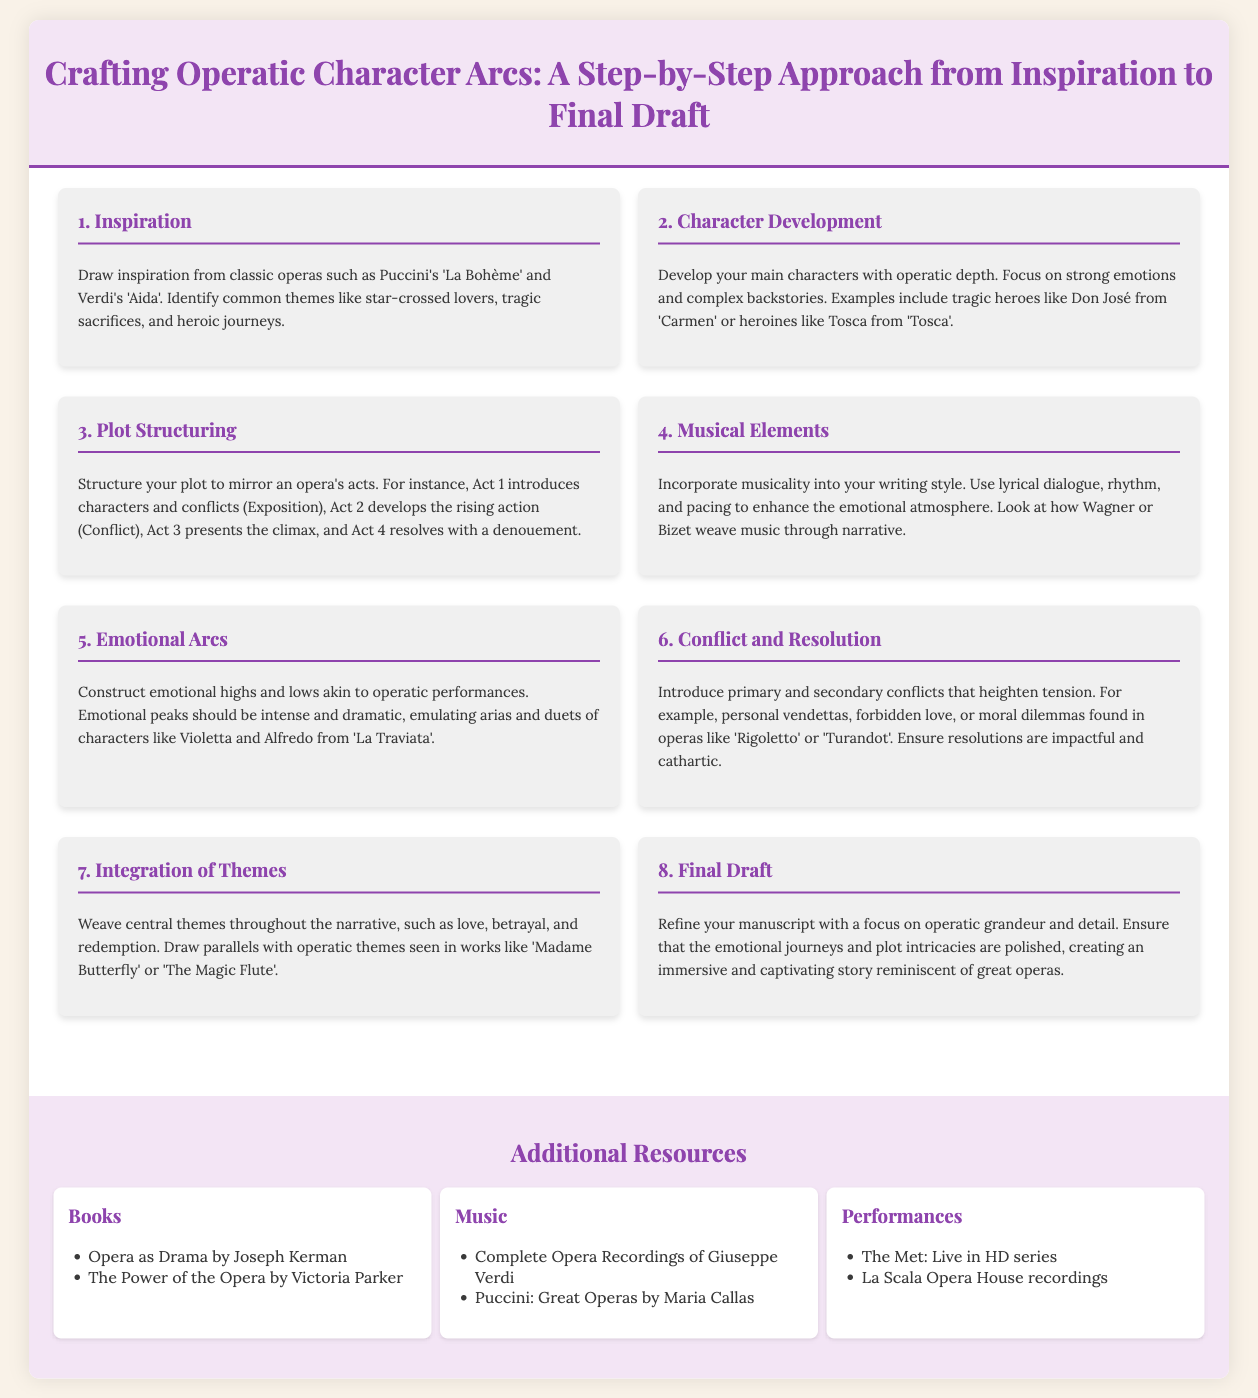What is the first step in crafting operatic character arcs? The first step involves drawing inspiration from classic operas and identifying common themes.
Answer: Inspiration Who is an example of a tragic hero in opera mentioned? The document lists Don José from 'Carmen' as a tragic hero example.
Answer: Don José How many steps are there in the process of crafting operatic character arcs? The infographic details a total of eight steps in the process.
Answer: Eight Which act of the plot structure introduces characters and conflicts? Act 1 is specified as the act that introduces characters and conflicts in the plot structure.
Answer: Act 1 What is recommended to incorporate into writing style for operatic character arcs? The document suggests using lyrical dialogue, rhythm, and pacing as elements to enhance the writing style.
Answer: Musicality What are two central themes to integrate into the narrative? Love and betrayal are highlighted as central themes to weave throughout the narrative.
Answer: Love, betrayal What type of emotional peaks should be constructed? The emotional peaks should be intense and dramatic, resembling arias and duets in operatic performances.
Answer: Intense and dramatic Name one book resource listed for additional reading. The infographic mentions "Opera as Drama" by Joseph Kerman as a book resource.
Answer: Opera as Drama Which opera house's recordings are suggested as a resource? The document recommends La Scala Opera House recordings as a performance resource.
Answer: La Scala Opera House 